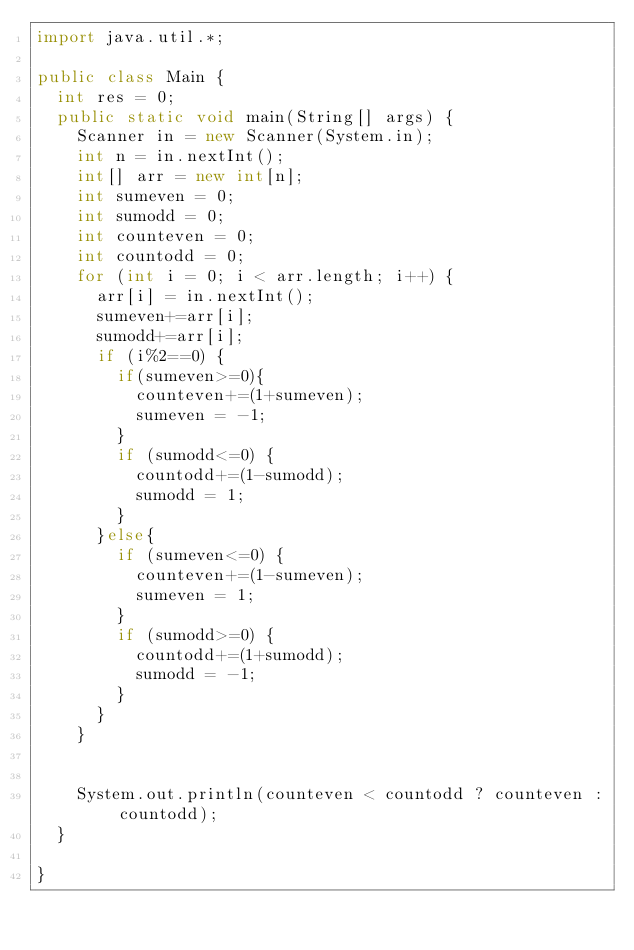<code> <loc_0><loc_0><loc_500><loc_500><_Java_>import java.util.*;

public class Main {
	int res = 0;
	public static void main(String[] args) {
		Scanner in = new Scanner(System.in);
		int n = in.nextInt();
		int[] arr = new int[n];
		int sumeven = 0;
		int sumodd = 0;
		int counteven = 0;
		int countodd = 0;
		for (int i = 0; i < arr.length; i++) {
			arr[i] = in.nextInt();
			sumeven+=arr[i];
			sumodd+=arr[i];
			if (i%2==0) {
				if(sumeven>=0){
					counteven+=(1+sumeven);
					sumeven = -1;
				}
				if (sumodd<=0) {
					countodd+=(1-sumodd);
					sumodd = 1;
				}
			}else{
				if (sumeven<=0) {
					counteven+=(1-sumeven);
					sumeven = 1;
				}
				if (sumodd>=0) {
					countodd+=(1+sumodd);
					sumodd = -1;
				}
			}
		}
		
		
		System.out.println(counteven < countodd ? counteven : countodd);
	}
	
}
</code> 